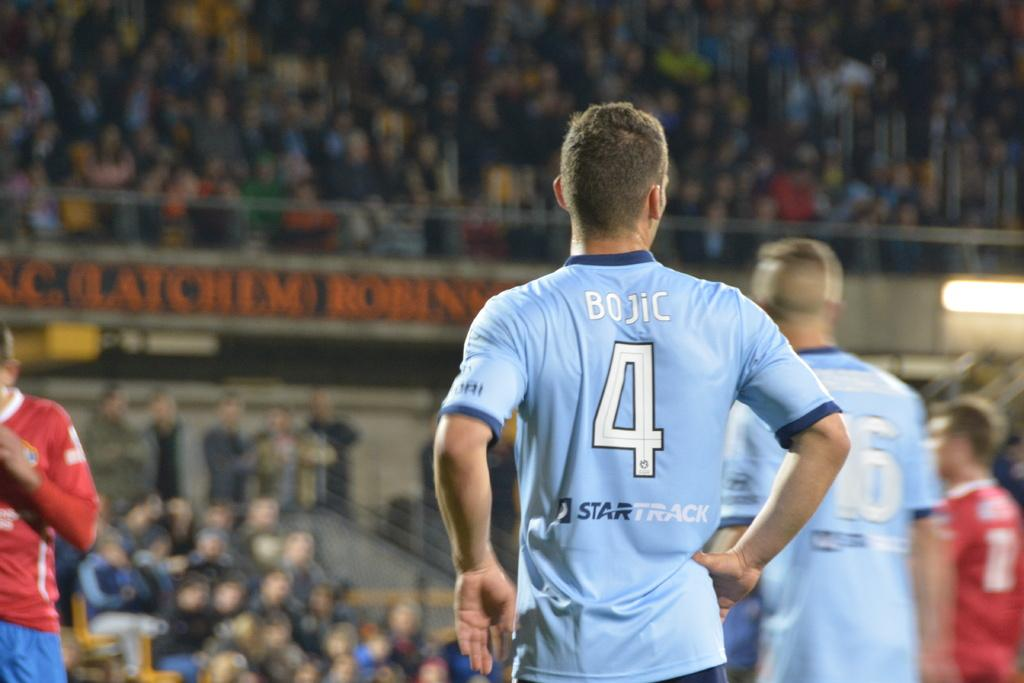How many people are in the image? There is a group of people in the image. What colors are the dresses of some people in the image? Some of the people are wearing blue and red color dresses. What can be seen in the background of the image? In the background, there are boards visible, along with lights and railing. How many people are in the background? There are many people in the background. How is the background of the image depicted? The background is blurred. How many books can be seen on the railing in the image? There are no books visible on the railing in the image. What type of mice are present in the background of the image? There are no mice present in the image. 